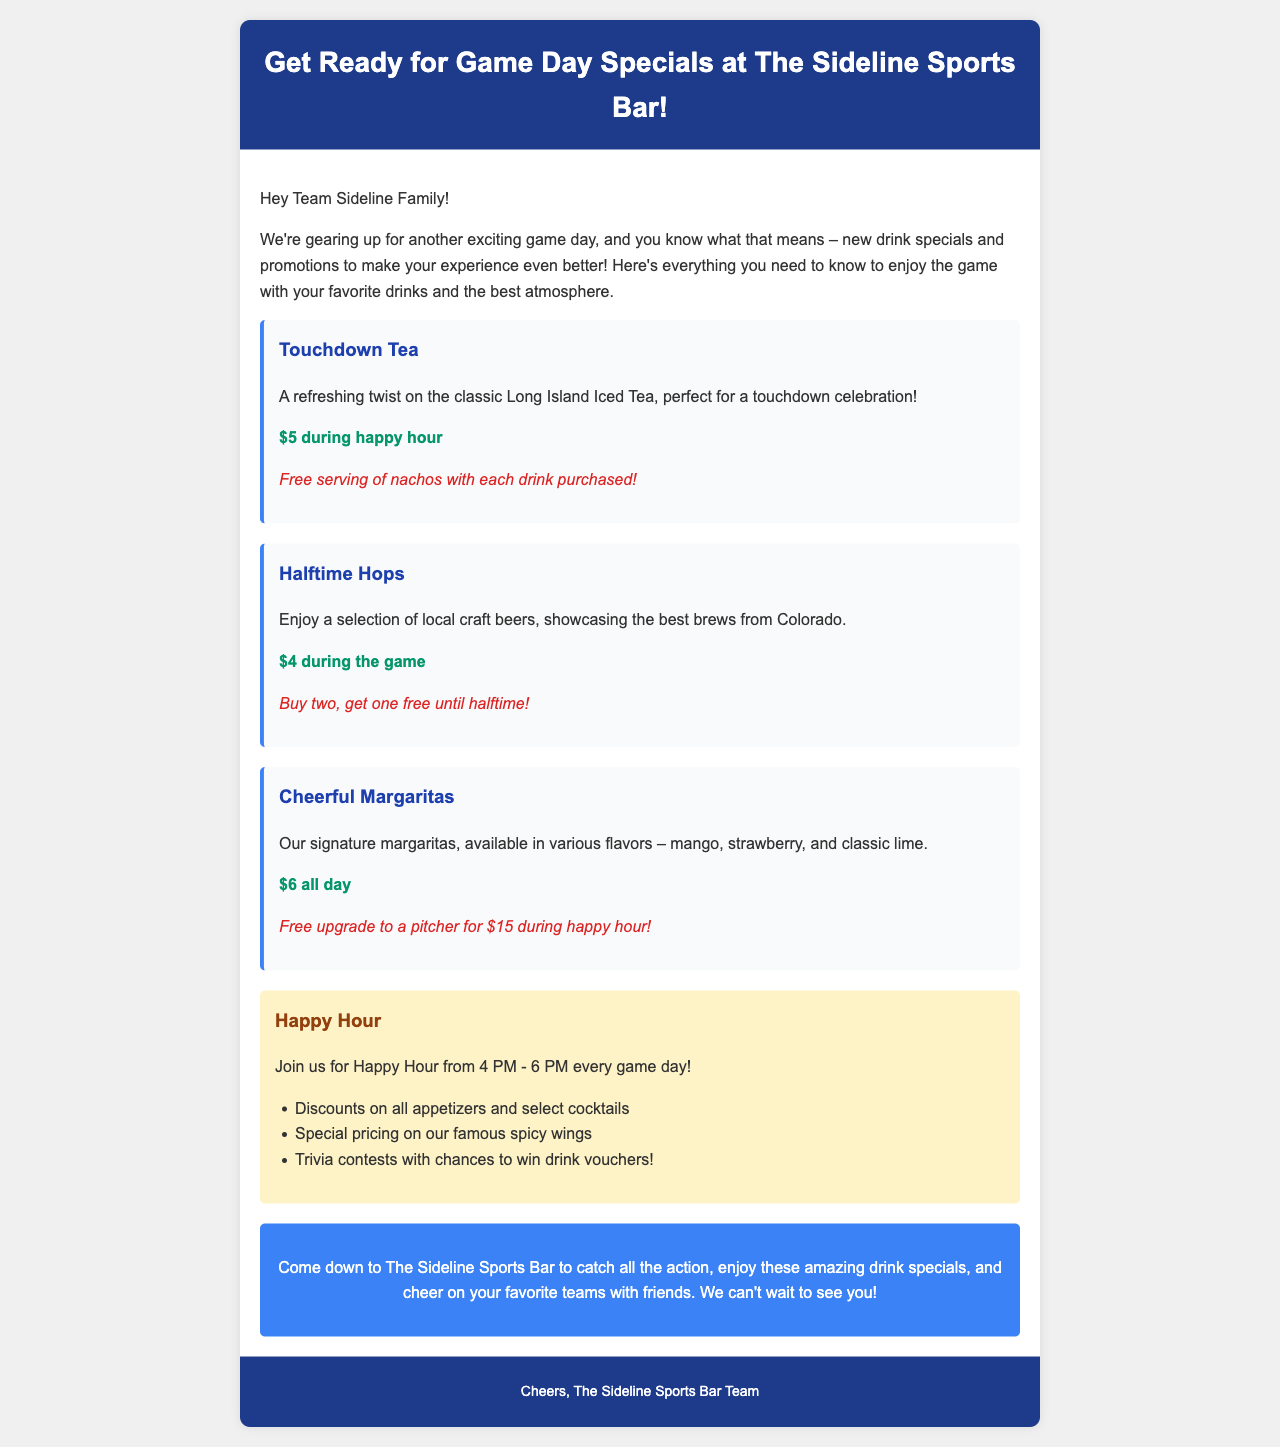what is the name of the special drink that comes with free nachos? The drink special is called "Touchdown Tea," which includes a free serving of nachos with each drink purchased.
Answer: Touchdown Tea what is the price of "Halftime Hops" during the game? The price of "Halftime Hops," which is a selection of local craft beers, is mentioned as $4 during the game.
Answer: $4 what time does happy hour start? The document states that Happy Hour begins at 4 PM every game day.
Answer: 4 PM what is the special offer on "Cheerful Margaritas" during happy hour? During happy hour, the special offer is a free upgrade to a pitcher for $15 with the purchase of "Cheerful Margaritas," available in various flavors.
Answer: Free upgrade to a pitcher for $15 how long does happy hour last? The duration of Happy Hour is from 4 PM to 6 PM, indicating that it lasts for 2 hours.
Answer: 2 hours what promotion is offered with "Halftime Hops" until halftime? The promotion with "Halftime Hops" is "Buy two, get one free," which is available until halftime.
Answer: Buy two, get one free what activities are mentioned during happy hour? The activities during Happy Hour include discounts on appetizers and select cocktails, special pricing on spicy wings, and trivia contests with chances to win drink vouchers.
Answer: Discounts on appetizers and select cocktails, special pricing on spicy wings, trivia contests who is the message addressed to? The message is addressed to the "Team Sideline Family," indicating the intended audience is the regular patrons of the bar.
Answer: Team Sideline Family 